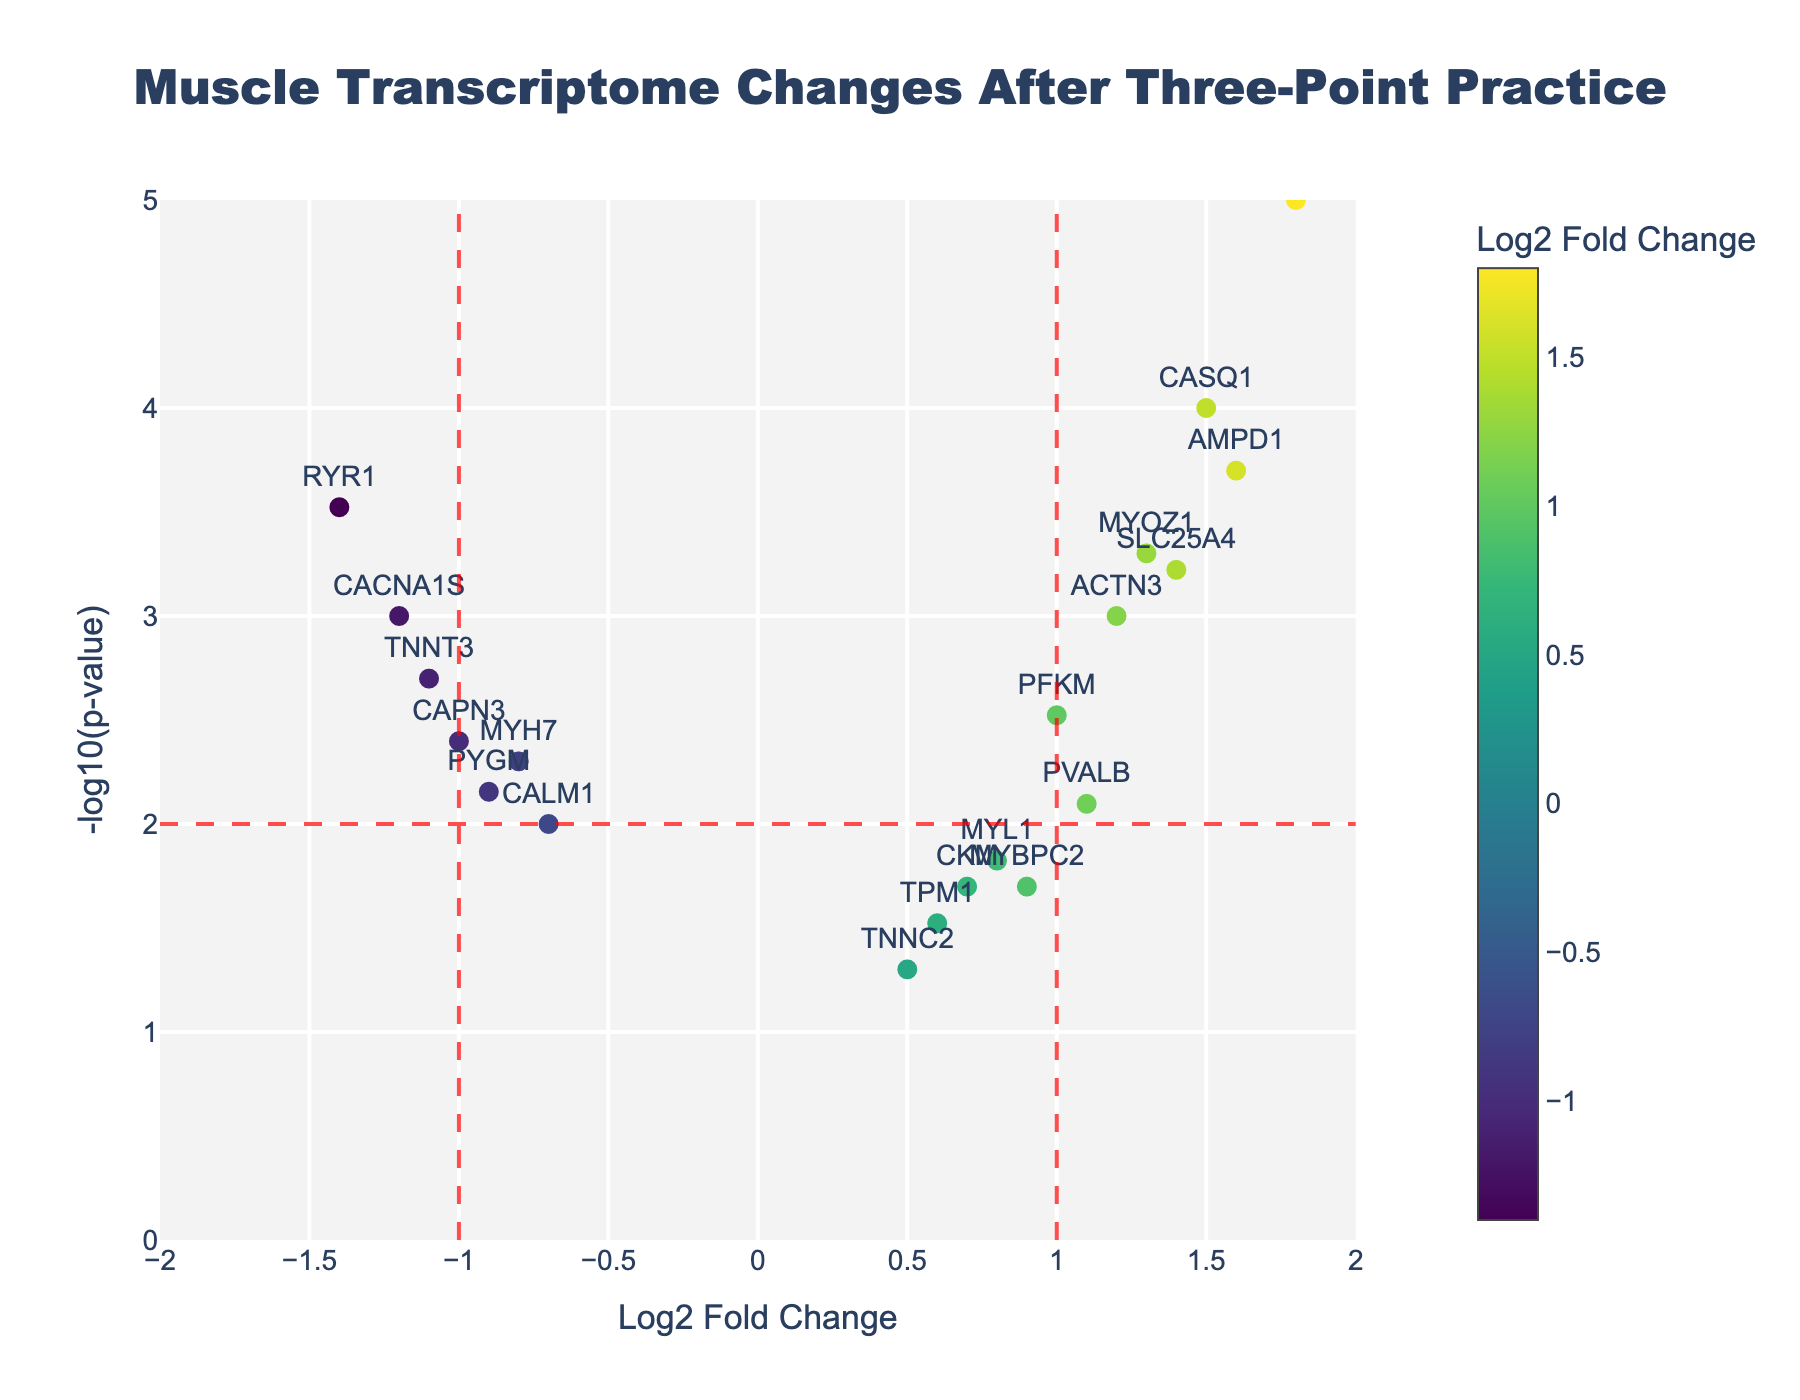What is the title of the plot? The title is displayed at the top center of the figure, formatted in bold.
Answer: Muscle Transcriptome Changes After Three-Point Practice What are the x-axis and y-axis labels in this plot? The labels are written along the respective axes: x-axis at the bottom and y-axis on the left side.
Answer: The x-axis is labeled "Log2 Fold Change" and the y-axis is labeled "-log10(p-value)" Which gene has the highest significance based on the p-value? The gene with the highest significance will have the highest -log10(p-value) value, which means it is visually the highest point on the y-axis.
Answer: ATP2A1 How many genes have a Log2 Fold Change of greater than 1? We need to count the number of data points with an x-coordinate (Log2 Fold Change) greater than 1.
Answer: 5 Which gene shows the most downregulation? The most downregulated gene would have the most negative Log2 Fold Change value, which is seen as the farthest point to the left on the x-axis.
Answer: RYR1 For the gene with the maximum fold change, what is its p-value? The gene with the maximum fold change has the most extreme Log2FoldChange value, examine its corresponding p-value from the data table.
Answer: 0.00001 How many genes have both Log2 Fold Change > 0 and -log10(p-value) > 2? Identify the points located in the top right quadrant beyond the vertical and horizontal threshold lines.
Answer: 6 Which gene is closest to the threshold significance level (p-value = 0.01)? A p-value of 0.01 corresponds to -log10(p-value) of 2, so look for the point closest to y=2.
Answer: TPM1 Is there any gene that has a Log2 Fold Change exactly 1.0? If so, which one and what is its p-value? Check the list for the gene with Log2 Fold Change of exactly 1.0, and state its p-value from the table.
Answer: Yes, PFKM with a p-value of 0.003 How many genes exhibit significant downregulation (Log2 Fold Change < -1 and p-value < 0.01)? Look for points below -1 on the x-axis and above 2 on the y-axis (since -log10(0.01) = 2).
Answer: 2 